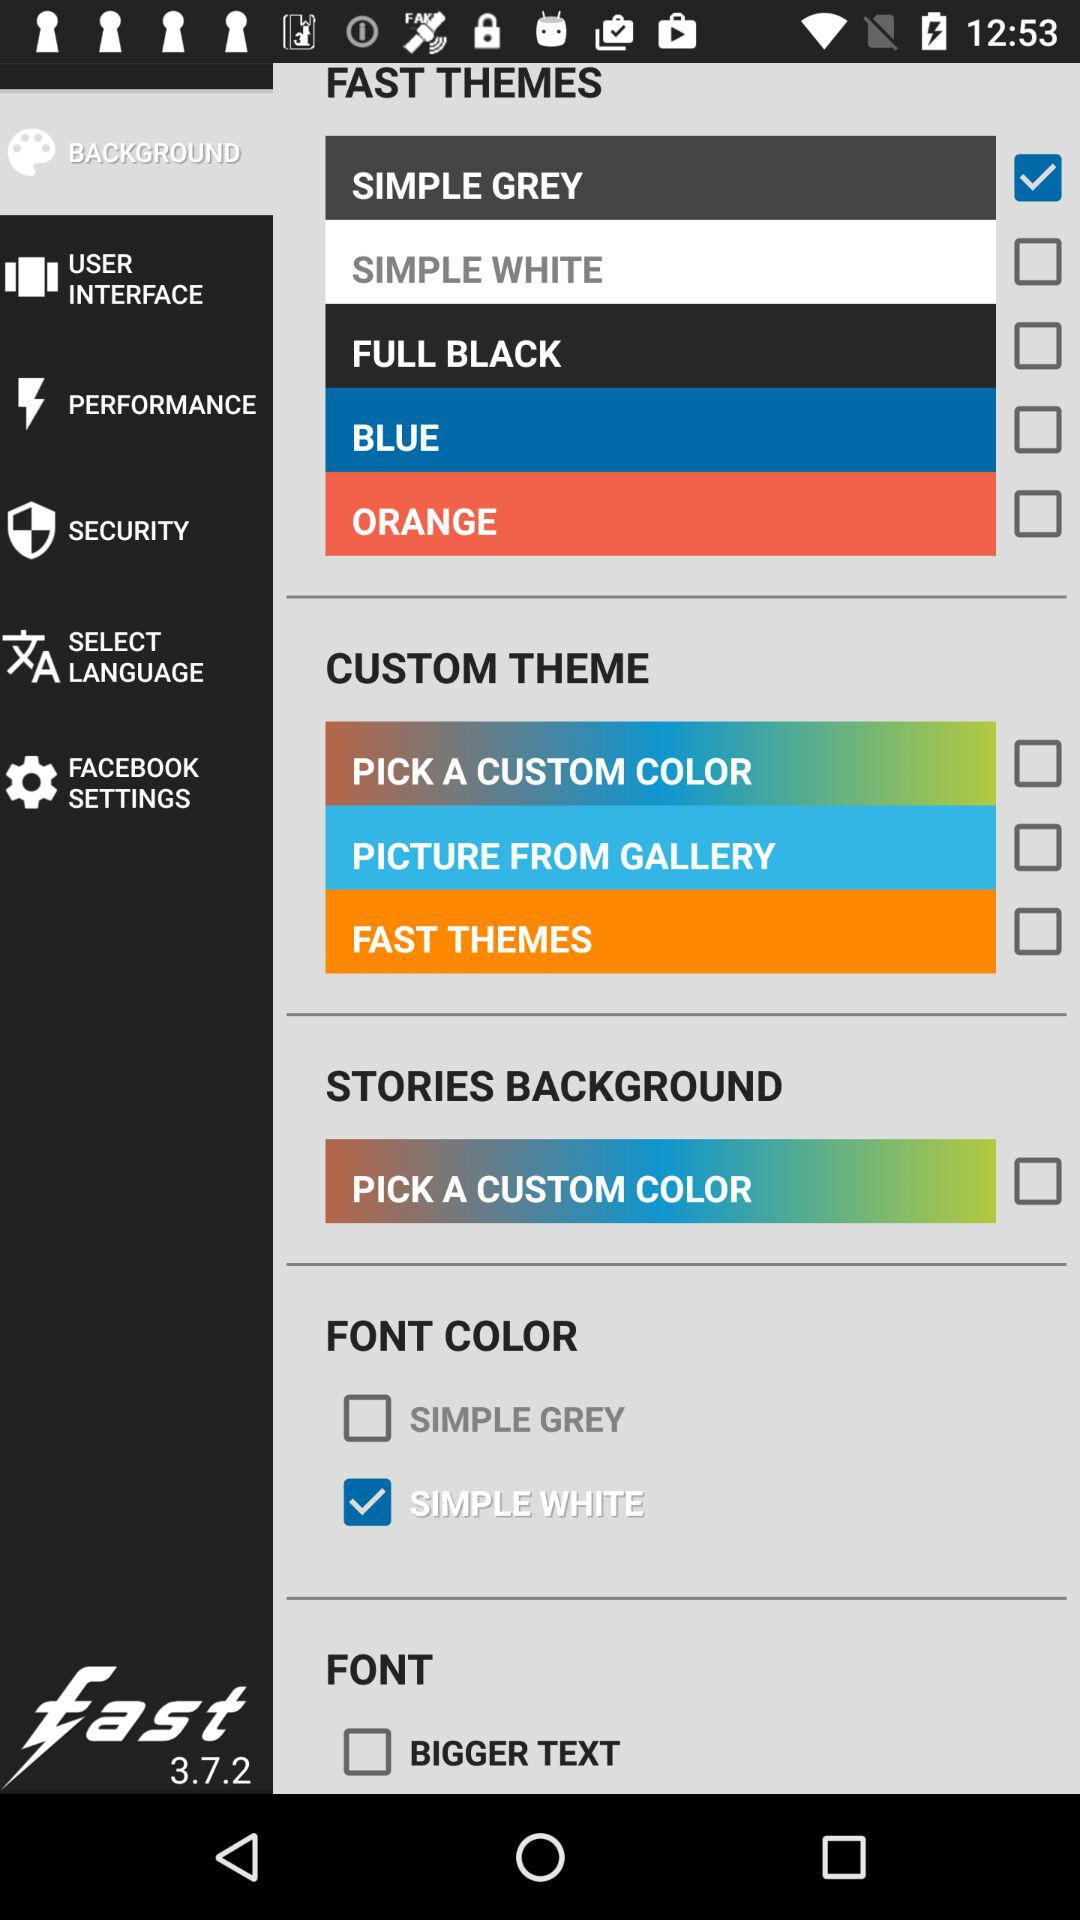Which is the selected option in "FAST THEMES"? The selected option is "SIMPLE GREY". 